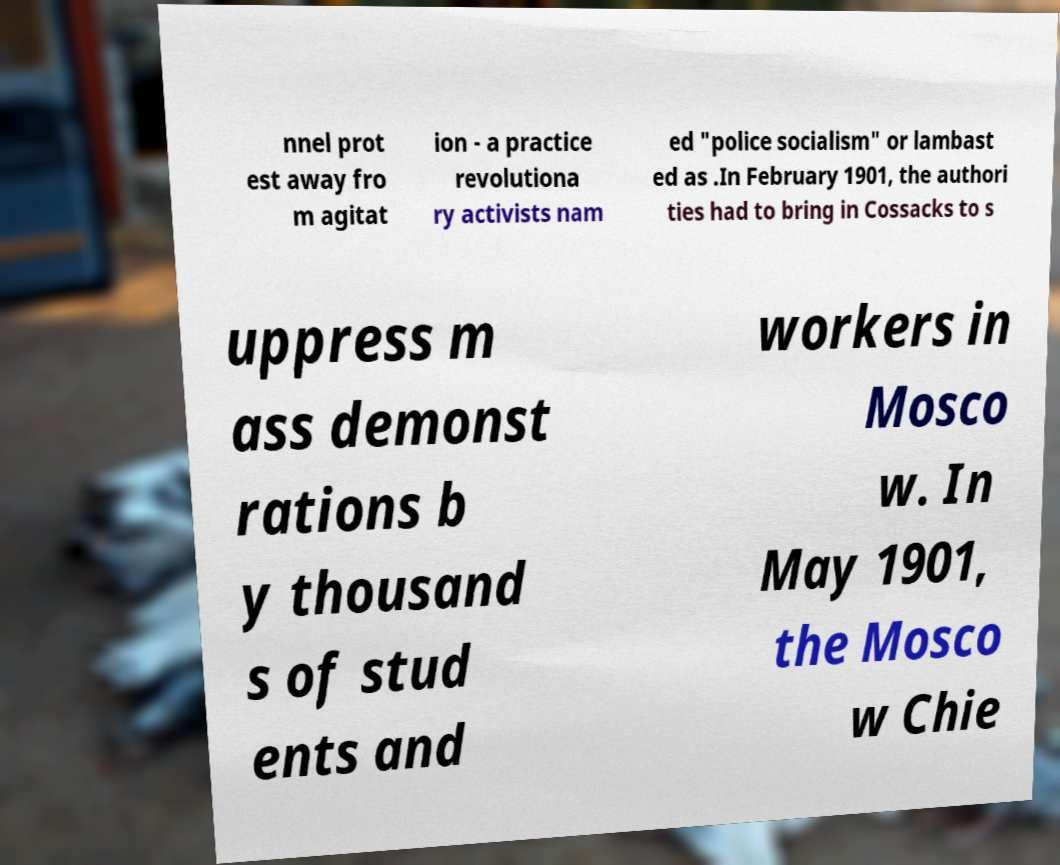Please read and relay the text visible in this image. What does it say? nnel prot est away fro m agitat ion - a practice revolutiona ry activists nam ed "police socialism" or lambast ed as .In February 1901, the authori ties had to bring in Cossacks to s uppress m ass demonst rations b y thousand s of stud ents and workers in Mosco w. In May 1901, the Mosco w Chie 